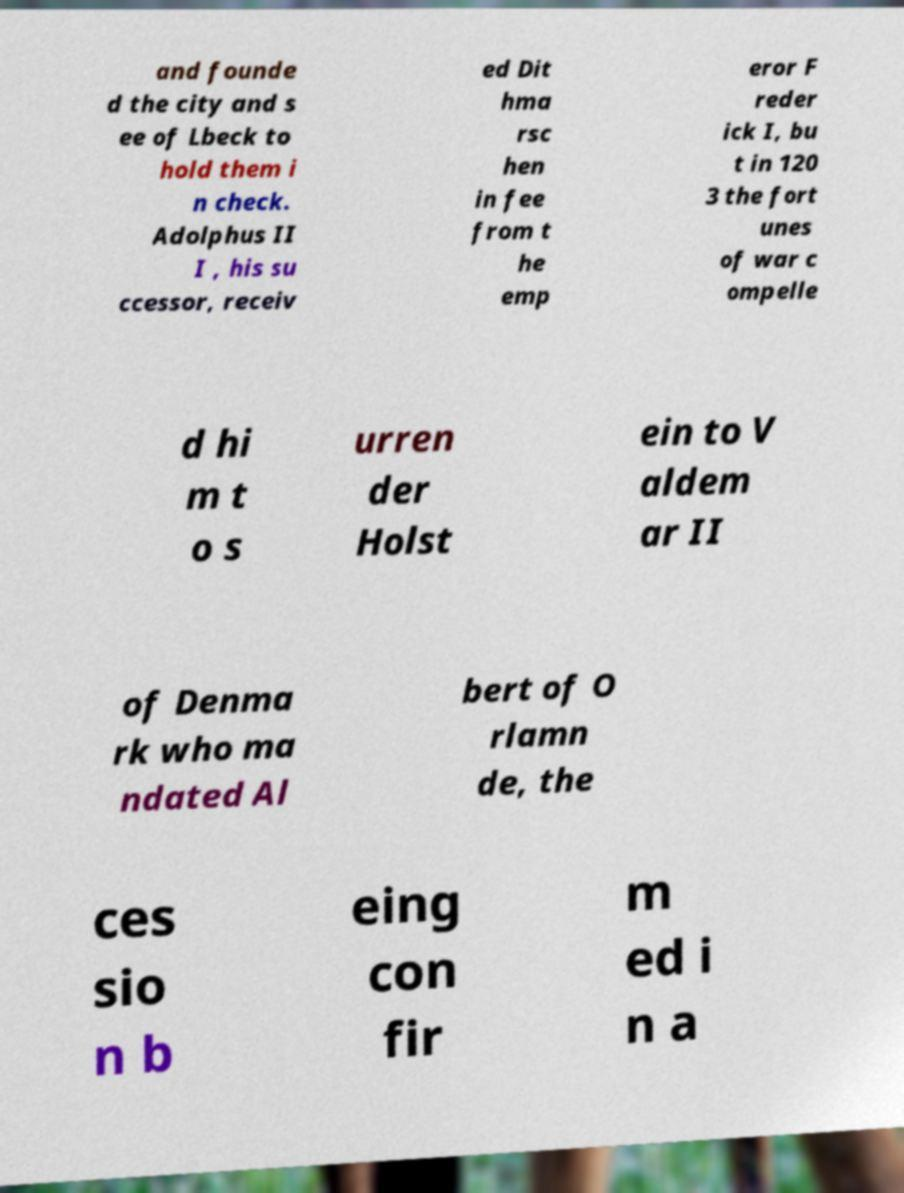Could you extract and type out the text from this image? and founde d the city and s ee of Lbeck to hold them i n check. Adolphus II I , his su ccessor, receiv ed Dit hma rsc hen in fee from t he emp eror F reder ick I, bu t in 120 3 the fort unes of war c ompelle d hi m t o s urren der Holst ein to V aldem ar II of Denma rk who ma ndated Al bert of O rlamn de, the ces sio n b eing con fir m ed i n a 